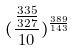Convert formula to latex. <formula><loc_0><loc_0><loc_500><loc_500>( \frac { \frac { 3 3 5 } { 3 2 7 } } { 1 0 } ) ^ { \frac { 3 8 9 } { 1 4 3 } }</formula> 